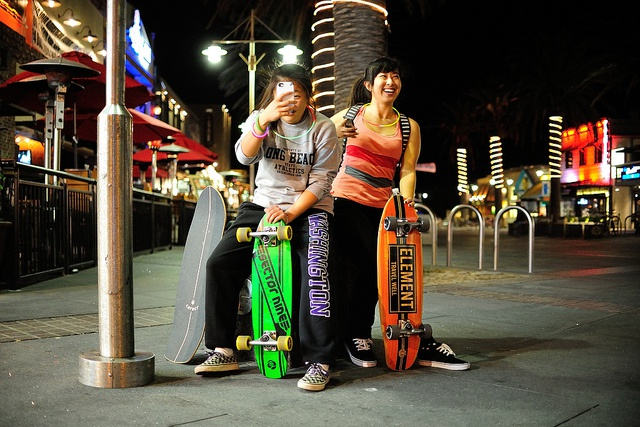Describe the objects in this image and their specific colors. I can see people in gold, black, red, and brown tones, people in gold, black, lightgray, darkgray, and gray tones, skateboard in gold, black, red, and brown tones, skateboard in gold, lime, black, and darkgreen tones, and skateboard in gold, darkgray, lightgray, beige, and black tones in this image. 